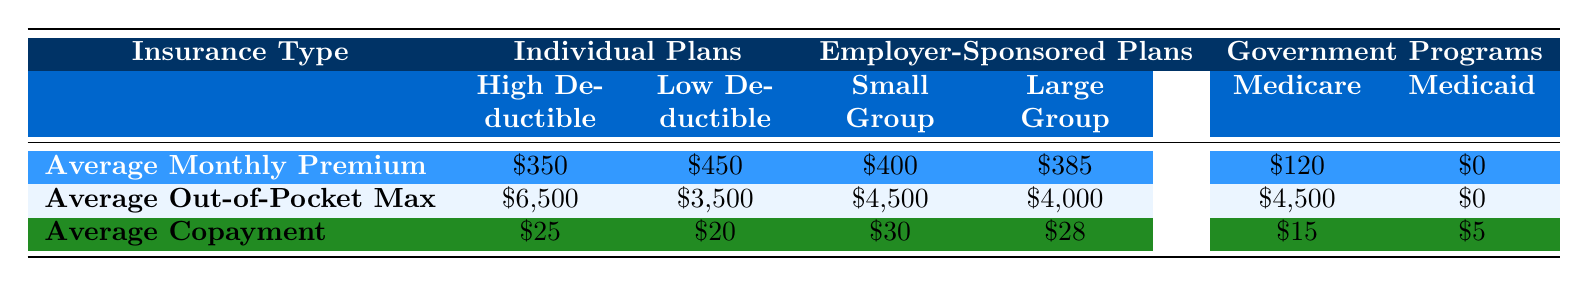What is the average monthly premium for Individual Plans with a high deductible? The table shows that the average monthly premium for Individual Plans with a high deductible is listed as $350.
Answer: $350 What is the average out-of-pocket maximum for Medicaid? According to the table, the average out-of-pocket maximum for Medicaid is $0.
Answer: $0 Which insurance type has the lowest average copayment? The lowest average copayment listed in the table is for Medicaid, which is $5.
Answer: $5 What is the difference in average out-of-pocket max between Individual Plans (high deductible) and Employer-Sponsored Plans (small group)? The average out-of-pocket max for Individual Plans (high deductible) is $6,500, and for Employer-Sponsored Plans (small group) it is $4,500. The difference is $6,500 - $4,500 = $2,000.
Answer: $2,000 Which insurance type has a higher average monthly premium, Employer-Sponsored Plans (large group) or Individual Plans (low deductible)? The average monthly premium for Employer-Sponsored Plans (large group) is $385 and for Individual Plans (low deductible) it is $450. Since $450 is greater than $385, Individual Plans (low deductible) has a higher premium.
Answer: Individual Plans (low deductible) What is the sum of the average monthly premiums for all Insurance Types listed? The average monthly premiums are: Individual Plans (high deductible) $350, Individual Plans (low deductible) $450, Employer-Sponsored Plans (small group) $400, Employer-Sponsored Plans (large group) $385, Medicare $120, and Medicaid $0. Adding them up gives $350 + $450 + $400 + $385 + $120 + $0 = $1,705.
Answer: $1,705 Is the average out-of-pocket max for Medicare greater than that for Employer-Sponsored Plans (large group)? The average out-of-pocket max for Medicare is $4,500, while for Employer-Sponsored Plans (large group) it is $4,000. Since $4,500 is greater than $4,000, the statement is true.
Answer: Yes What is the average copayment for Employer-Sponsored Plans (small group) compared to Individual Plans (high deductible)? The average copayment for Employer-Sponsored Plans (small group) is $30, while for Individual Plans (high deductible) it is $25. Comparing the two, $30 is greater than $25.
Answer: Employer-Sponsored Plans (small group) Calculate the average of all the average out-of-pocket max values presented in the table. The average out-of-pocket max values are: $6,500 (Individual Plans - high deductible), $3,500 (Individual Plans - low deductible), $4,500 (Employer-Sponsored Plans - small group), $4,000 (Employer-Sponsored Plans - large group), $4,500 (Medicare), and $0 (Medicaid). The sum is $6,500 + $3,500 + $4,500 + $4,000 + $4,500 + $0 = $23,000. There are 6 values, so the average is $23,000 / 6 ≈ $3,833.33.
Answer: $3,833.33 What percentage of the average monthly premium for Medicare is the average monthly premium for Individual Plans (high deductible)? The average monthly premium for Medicare is $120, and for Individual Plans (high deductible) it is $350. To find the percentage: ($120 / $350) * 100% ≈ 34.29%.
Answer: 34.29% 